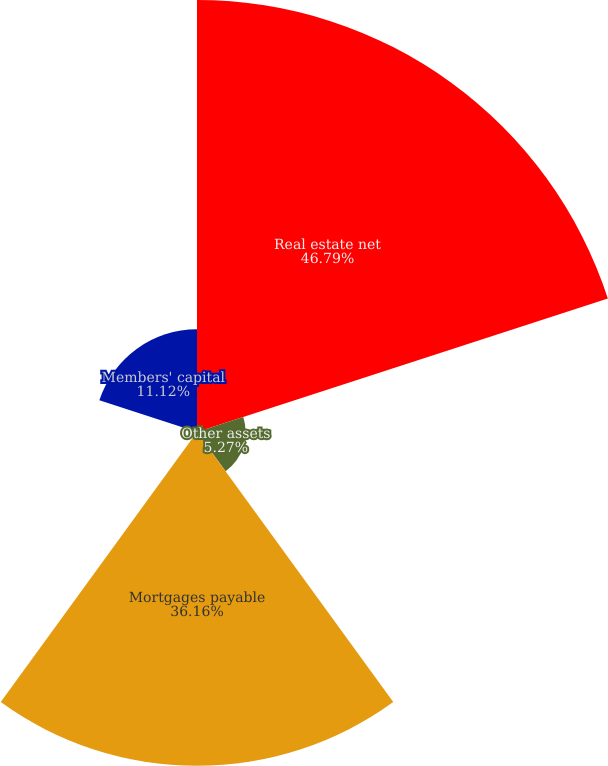Convert chart. <chart><loc_0><loc_0><loc_500><loc_500><pie_chart><fcel>Real estate net<fcel>Other assets<fcel>Mortgages payable<fcel>Other liabilities<fcel>Members' capital<nl><fcel>46.79%<fcel>5.27%<fcel>36.16%<fcel>0.66%<fcel>11.12%<nl></chart> 